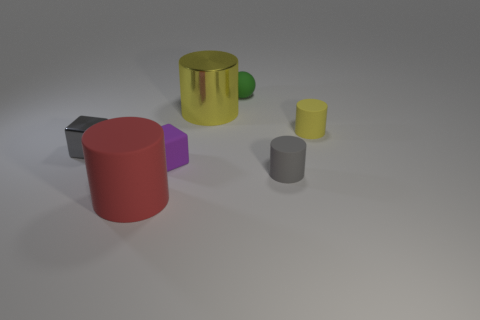Does the arrangement of the items suggest any specific pattern or purpose? The objects do not seem to be arranged in a particular pattern; it appears to be a random assortment of geometric shapes and colors, possibly for the purpose of a visual or artistic composition. What is the lighting like in this scene? The lighting in the scene seems diffuse and overhead, casting soft shadows for each object and contributing to a tranquil and neutral setting. 